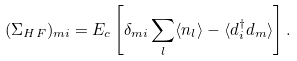Convert formula to latex. <formula><loc_0><loc_0><loc_500><loc_500>( \Sigma _ { H F } ) _ { m i } = E _ { c } \left [ \delta _ { m i } \sum _ { l } \langle n _ { l } \rangle - \langle d _ { i } ^ { \dagger } d _ { m } \rangle \right ] .</formula> 